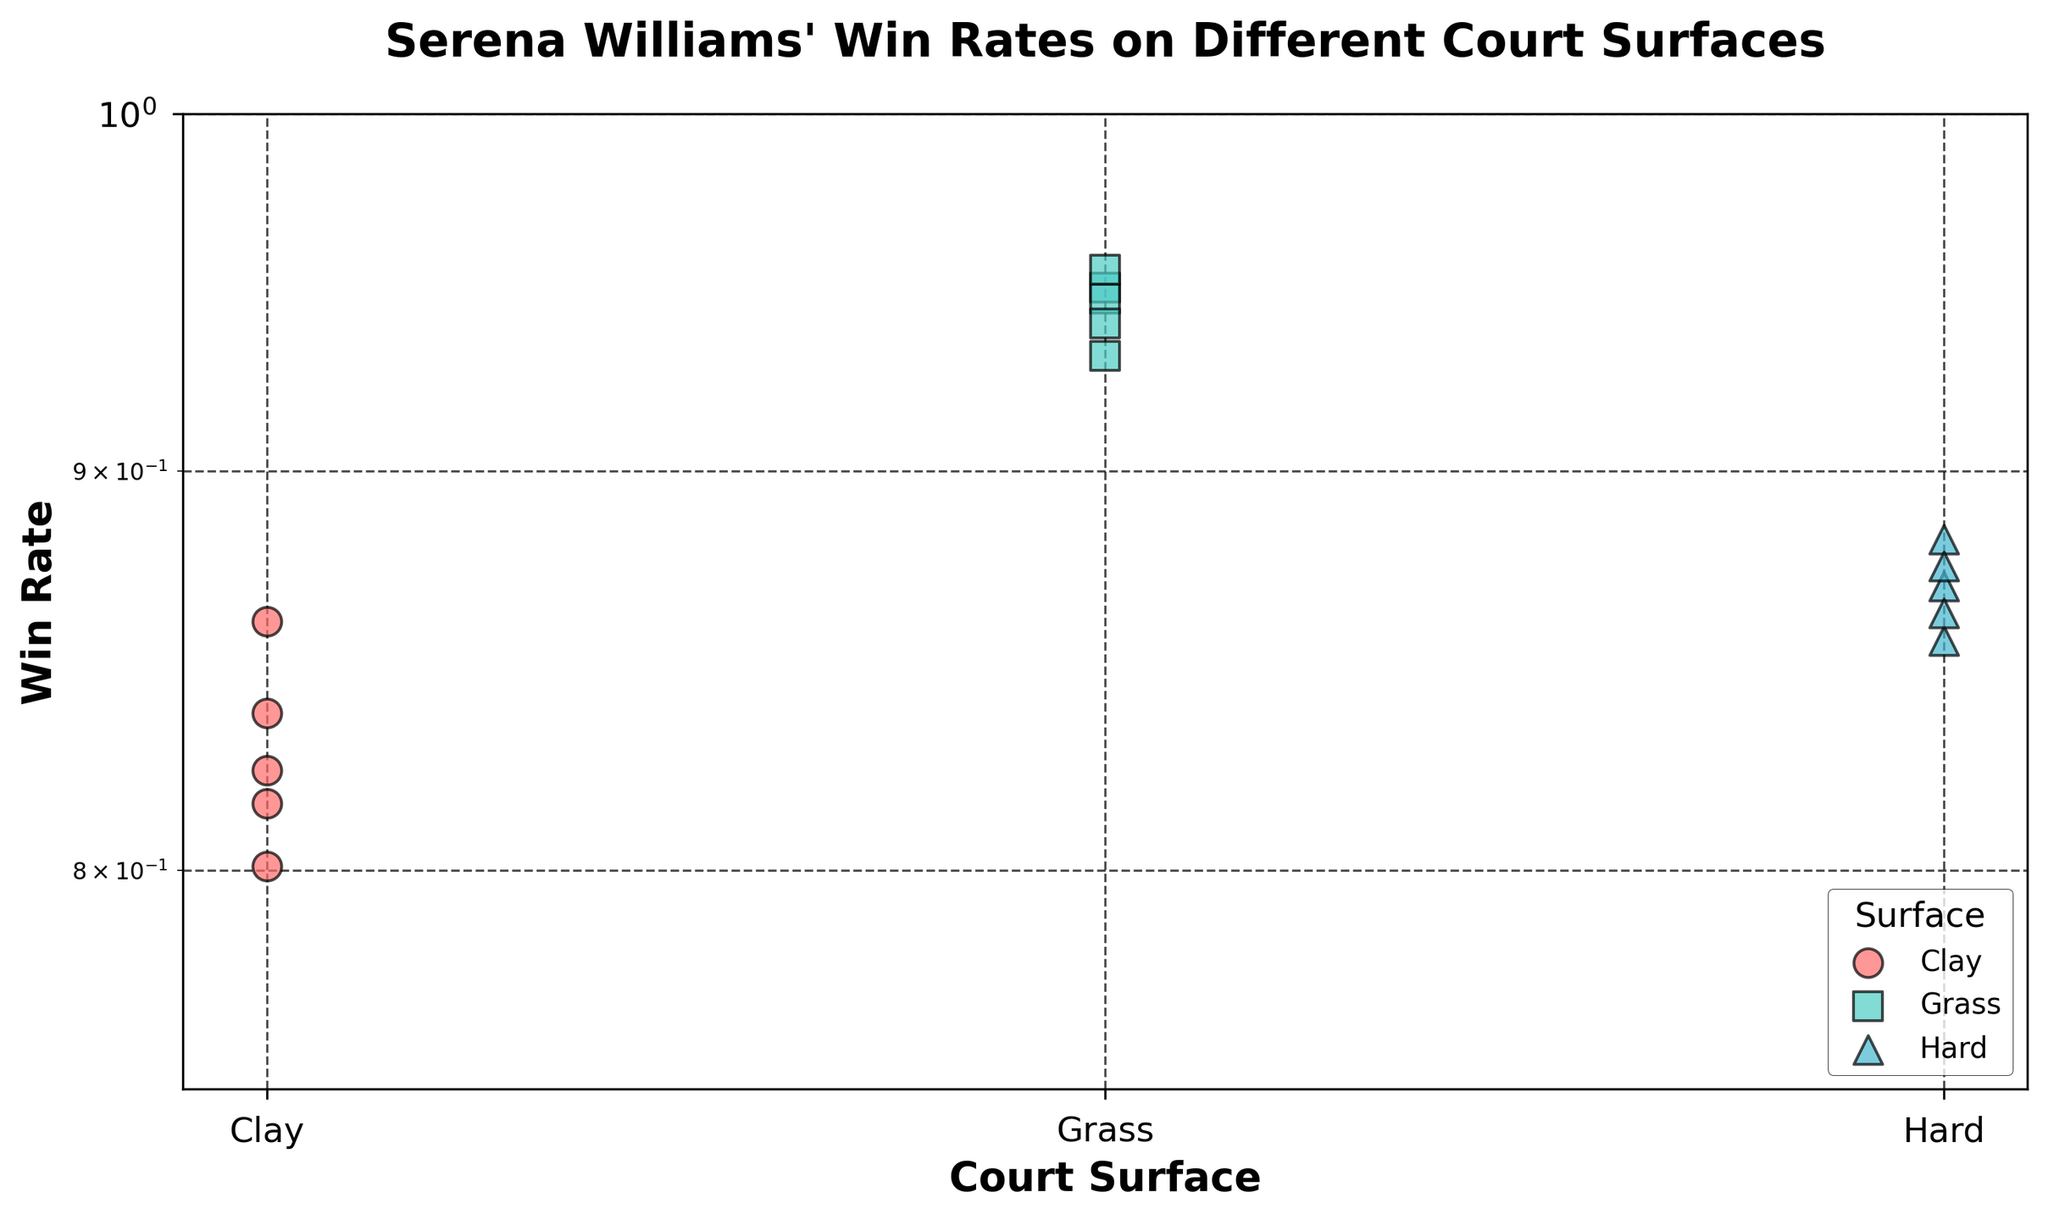What is the title of the figure? The title of the figure is displayed at the top and reads "Serena Williams' Win Rates on Different Court Surfaces".
Answer: Serena Williams' Win Rates on Different Court Surfaces What court surface has the highest win rates for Serena Williams? To identify the court surface with the highest win rates, observe the clusters of data points and identify which group indicates higher values on the y-axis. Grass has the highest win rates, all above 0.93.
Answer: Grass How many win rate data points are there for each court surface? Count the number of data points for each color/marker combination representing different court surfaces in the scatter plot. Each surface has 5 data points.
Answer: 5 Which court surface shows the lowest individual win rate for Serena Williams? And what is that win rate? Observe the lowest data point across the different groups by checking their y-axis positions. The lowest win rate is on the Clay surface with a win rate of 0.801.
Answer: Clay, 0.801 Compare the average win rates on clay and hard courts. Which one is higher? First, calculate the average win rates for both surfaces by summing their rates and dividing by 5. Clay: (0.838 + 0.824 + 0.861 + 0.801 + 0.816)/5 = 0.828. Hard: (0.870 + 0.856 + 0.882 + 0.863 + 0.875)/5 = 0.8692. The hard court has a higher average win rate.
Answer: Hard What is the range of win rates observed on grass courts? The range is the difference between the maximum and minimum win rates on grass courts. Maximum is 0.955 and minimum is 0.931. Range = 0.955 - 0.931 = 0.024
Answer: 0.024 Which court surface has the smallest spread in win rates? The spread can be observed by checking the range of win rates for each surface. Grass courts appear to have the most tightly clustered win rates with minimal variation.
Answer: Grass What is unique about the y-axis scale on the plot? The y-axis is set to a log scale as indicated by the "log" label. This transformation helps in better visualizing small differences when the values are close.
Answer: Log scale On which court surface does Serena Williams show the least variability in her performance? Least variability can be assessed by how tightly grouped the win rates are. Grass court win rates are very close to each other, showing least variability.
Answer: Grass What is the y-axis range for the win rates in the plot? The y-axis range for win rates starts at 0.75 and goes up to 1.
Answer: 0.75 to 1.0 